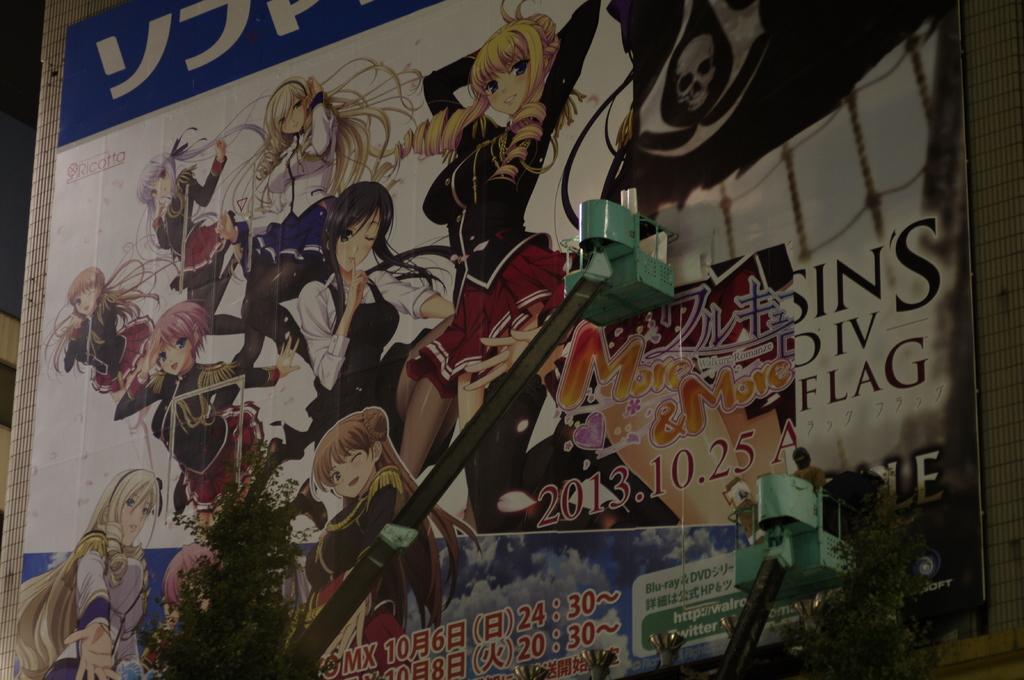How would you summarize this image in a sentence or two? In this picture we can see a poster on the surface, here we can see people, plants, some text and some objects. 